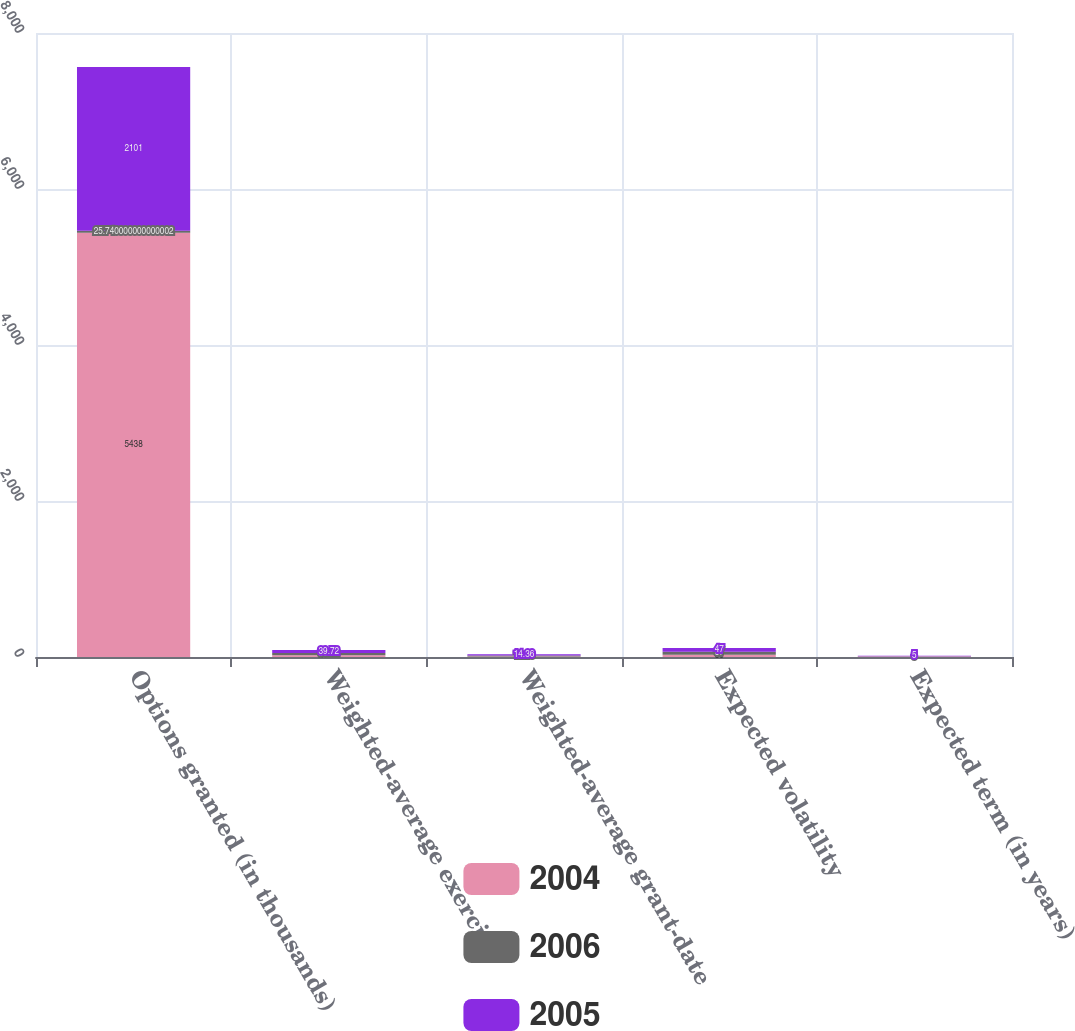Convert chart to OTSL. <chart><loc_0><loc_0><loc_500><loc_500><stacked_bar_chart><ecel><fcel>Options granted (in thousands)<fcel>Weighted-average exercise<fcel>Weighted-average grant-date<fcel>Expected volatility<fcel>Expected term (in years)<nl><fcel>2004<fcel>5438<fcel>21.48<fcel>7.61<fcel>30<fcel>5<nl><fcel>2006<fcel>25.74<fcel>30.12<fcel>12.18<fcel>37<fcel>5<nl><fcel>2005<fcel>2101<fcel>39.72<fcel>14.36<fcel>47<fcel>5<nl></chart> 